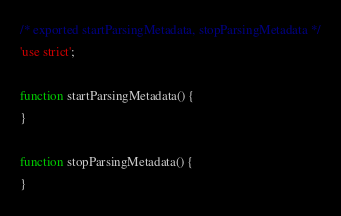Convert code to text. <code><loc_0><loc_0><loc_500><loc_500><_JavaScript_>/* exported startParsingMetadata, stopParsingMetadata */
'use strict';

function startParsingMetadata() {
}

function stopParsingMetadata() {
}
</code> 